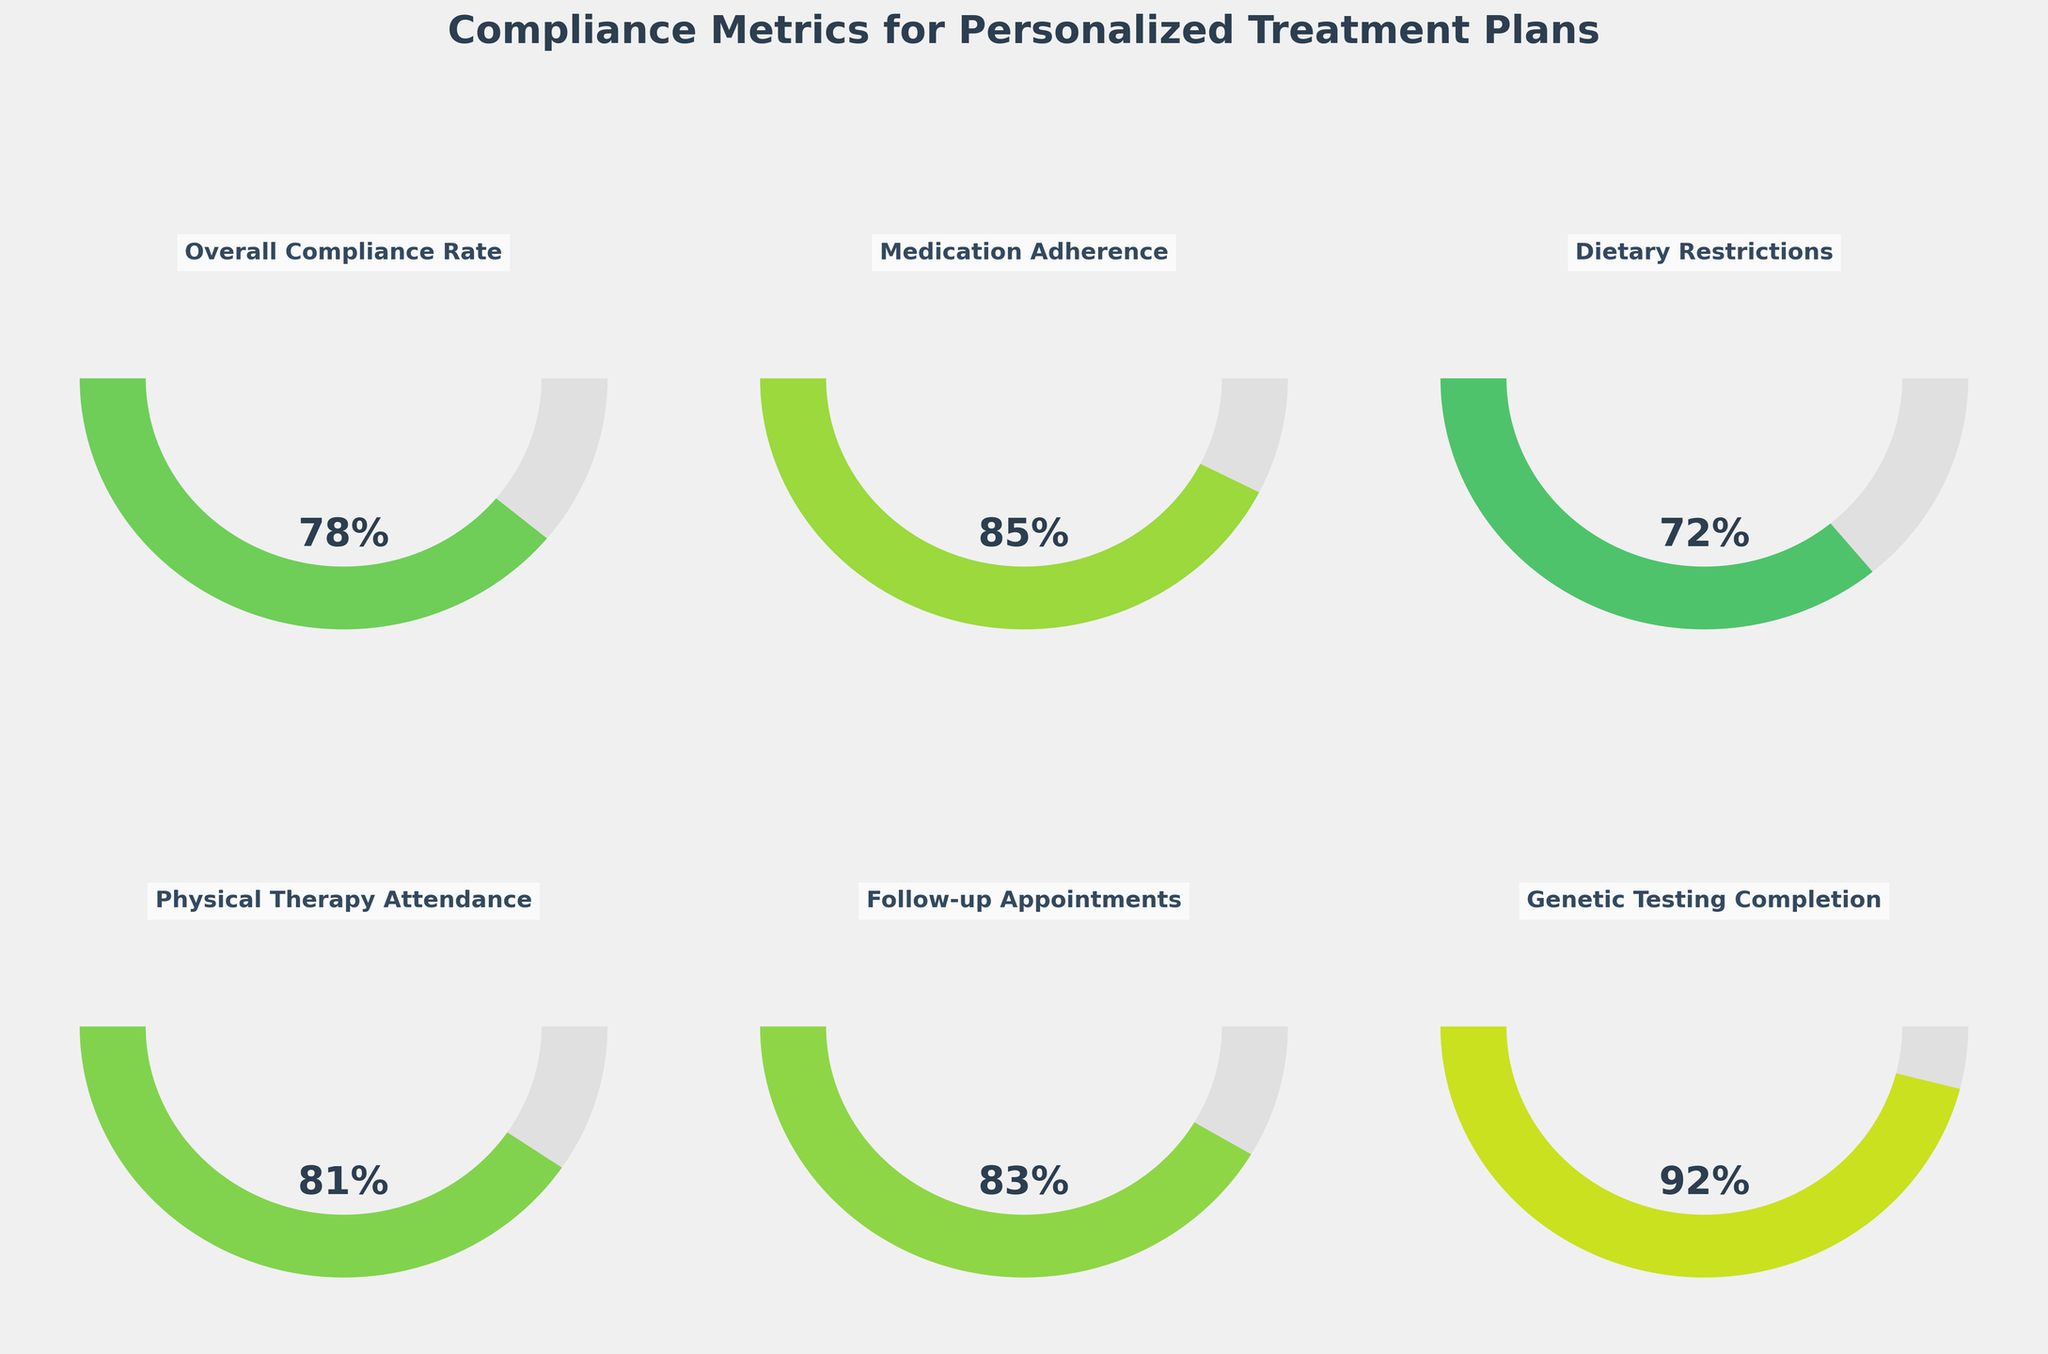What is the overall compliance rate? The overall compliance rate is displayed as 78% on the first gauge chart.
Answer: 78% Which compliance metric has the highest adherence? The genetic testing completion metric shows the highest adherence, displayed as 92% on the gauge chart.
Answer: Genetic Testing Completion How does the dietary restrictions compliance rate compare to the medication adherence rate? The dietary restrictions compliance rate is 72%, while the medication adherence rate is 85%. The dietary restrictions compliance rate is 13 percentage points lower than the medication adherence rate.
Answer: The dietary restrictions compliance rate is lower by 13 percentage points What is the average compliance rate across all metrics? Sum all the compliance rates: (78% + 85% + 72% + 81% + 83% + 92%) = 491%. Divide by the number of metrics (6): 491% / 6 = 81.83%.
Answer: 81.83% Which compliance metric is the closest to the overall compliance rate? The overall compliance rate is 78%. The compliance rates are as follows: Medication Adherence (85%), Dietary Restrictions (72%), Physical Therapy Attendance (81%), Follow-up Appointments (83%), and Genetic Testing Completion (92%). Physical Therapy Attendance at 81% is the closest to the overall compliance rate of 78%, with a difference of 3 percentage points.
Answer: Physical Therapy Attendance By how many percentage points does genetic testing completion exceed dietary restrictions compliance? The genetic testing completion rate is 92% and the dietary restrictions compliance rate is 72%. So, 92% - 72% = 20 percentage points.
Answer: 20 percentage points Which metric has the lowest compliance rate and what is its value? The Dietary Restrictions metric has the lowest compliance rate, shown as 72% on the gauge chart.
Answer: Dietary Restrictions, 72% What percentage of compliance metrics are above 80%? There are six metrics in total: Overall Compliance Rate (78%), Medication Adherence (85%), Dietary Restrictions (72%), Physical Therapy Attendance (81%), Follow-up Appointments (83%), and Genetic Testing Completion (92%). Four out of the six metrics are above 80%.
Answer: 66.67% (4 out of 6) What is the difference between the highest and lowest compliance rates? The highest compliance rate is Genetic Testing Completion at 92%, and the lowest is Dietary Restrictions at 72%. The difference is 92% - 72% = 20%.
Answer: 20% Which compliance metric has a rate closest to 80%? The compliance metrics are Overall Compliance Rate (78%), Medication Adherence (85%), Dietary Restrictions (72%), Physical Therapy Attendance (81%), Follow-up Appointments (83%), and Genetic Testing Completion (92%). Physical Therapy Attendance at 81% is the closest to 80%.
Answer: Physical Therapy Attendance, 81% 